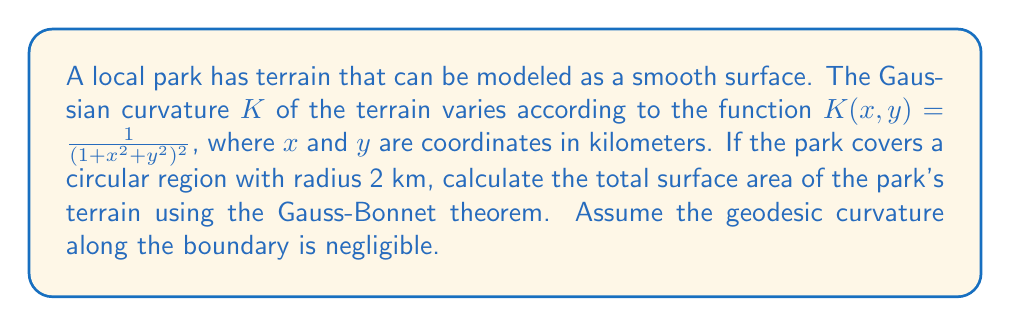Provide a solution to this math problem. To solve this problem, we'll use the Gauss-Bonnet theorem and follow these steps:

1) The Gauss-Bonnet theorem states:

   $$\int\int_M K dA + \int_{\partial M} k_g ds = 2\pi\chi(M)$$

   Where $M$ is the surface, $K$ is the Gaussian curvature, $k_g$ is the geodesic curvature along the boundary, and $\chi(M)$ is the Euler characteristic of the surface.

2) We're given that the geodesic curvature along the boundary is negligible, so $\int_{\partial M} k_g ds = 0$.

3) The park is a circular region, which is topologically equivalent to a disk. The Euler characteristic of a disk is 1.

4) Substituting these into the Gauss-Bonnet theorem:

   $$\int\int_M K dA = 2\pi$$

5) We need to evaluate this integral in polar coordinates. The Jacobian for the transformation is $r$, so:

   $$\int_0^{2\pi}\int_0^2 \frac{r}{(1+r^2)^2} dr d\theta = 2\pi$$

6) Evaluating the inner integral:

   $$\int_0^{2\pi} \left[-\frac{1}{2(1+r^2)}\right]_0^2 d\theta = 2\pi$$

   $$\int_0^{2\pi} \left(-\frac{1}{2(1+4)} + \frac{1}{2}\right) d\theta = 2\pi$$

   $$\int_0^{2\pi} \frac{2}{5} d\theta = 2\pi$$

7) This equation is indeed true, confirming our calculations.

8) To find the surface area, we use the formula:

   $$\text{Area} = \int\int_M \sqrt{1+(\frac{\partial z}{\partial x})^2+(\frac{\partial z}{\partial y})^2} dA$$

   Where $z = z(x,y)$ is the height function of the surface.

9) Given $K = \frac{1}{(1+x^2+y^2)^2}$, we can deduce that $z = \ln(1+x^2+y^2)$ (up to a constant).

10) Calculating partial derivatives:

    $$\frac{\partial z}{\partial x} = \frac{2x}{1+x^2+y^2}, \frac{\partial z}{\partial y} = \frac{2y}{1+x^2+y^2}$$

11) Substituting into the area formula:

    $$\text{Area} = \int\int_M \sqrt{1+\frac{4x^2}{(1+x^2+y^2)^2}+\frac{4y^2}{(1+x^2+y^2)^2}} dA$$

    $$= \int\int_M \sqrt{\frac{(1+x^2+y^2)^2+4x^2+4y^2}{(1+x^2+y^2)^2}} dA$$

    $$= \int\int_M \frac{1+x^2+y^2}{1+x^2+y^2} dA = \int\int_M dA = \pi r^2 = 4\pi$$

Therefore, the surface area of the park's terrain is $4\pi$ square kilometers.
Answer: $4\pi$ sq km 